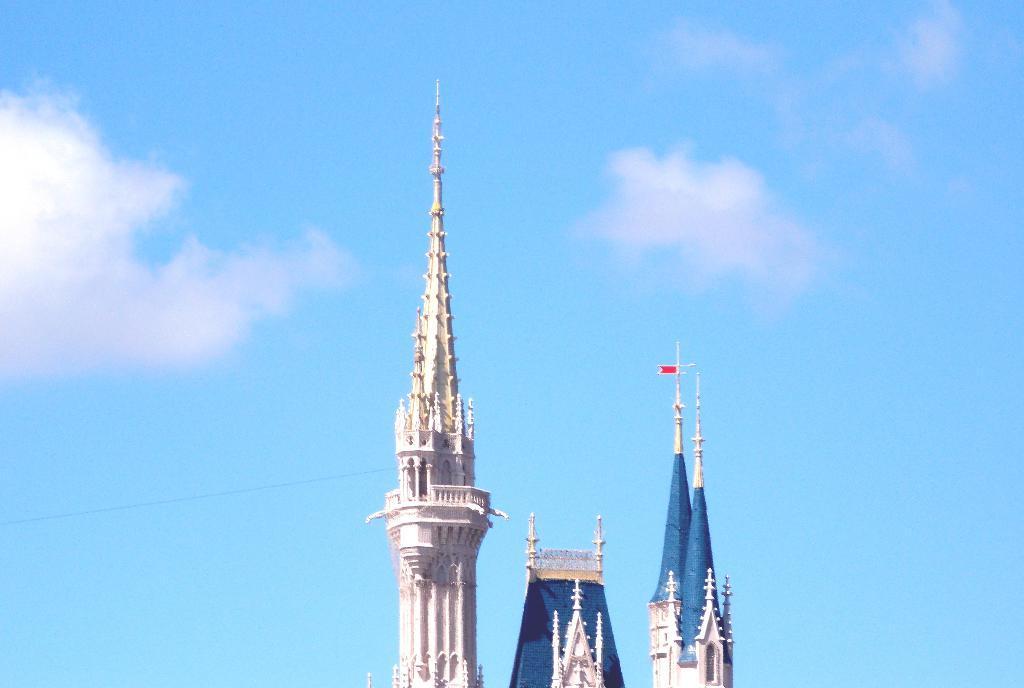Describe this image in one or two sentences. In this picture we can see the top of a building. Sky is blue in color and cloudy. 